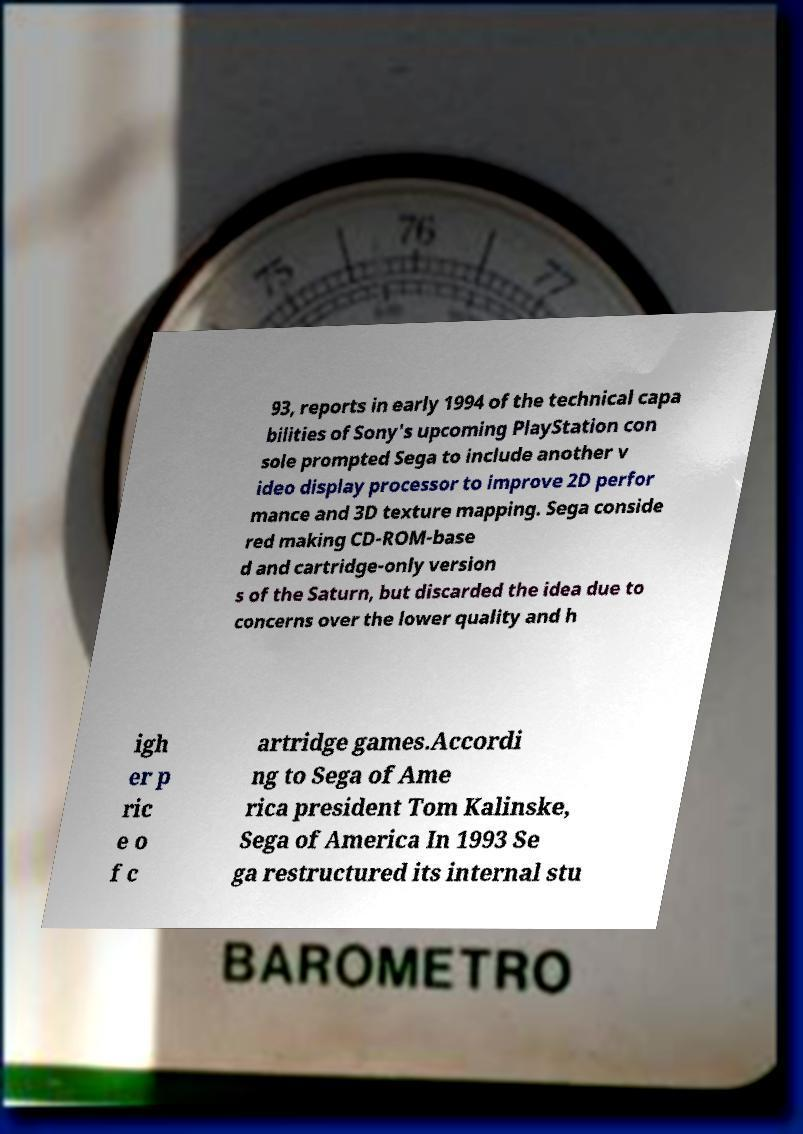Could you extract and type out the text from this image? 93, reports in early 1994 of the technical capa bilities of Sony's upcoming PlayStation con sole prompted Sega to include another v ideo display processor to improve 2D perfor mance and 3D texture mapping. Sega conside red making CD-ROM-base d and cartridge-only version s of the Saturn, but discarded the idea due to concerns over the lower quality and h igh er p ric e o f c artridge games.Accordi ng to Sega of Ame rica president Tom Kalinske, Sega of America In 1993 Se ga restructured its internal stu 